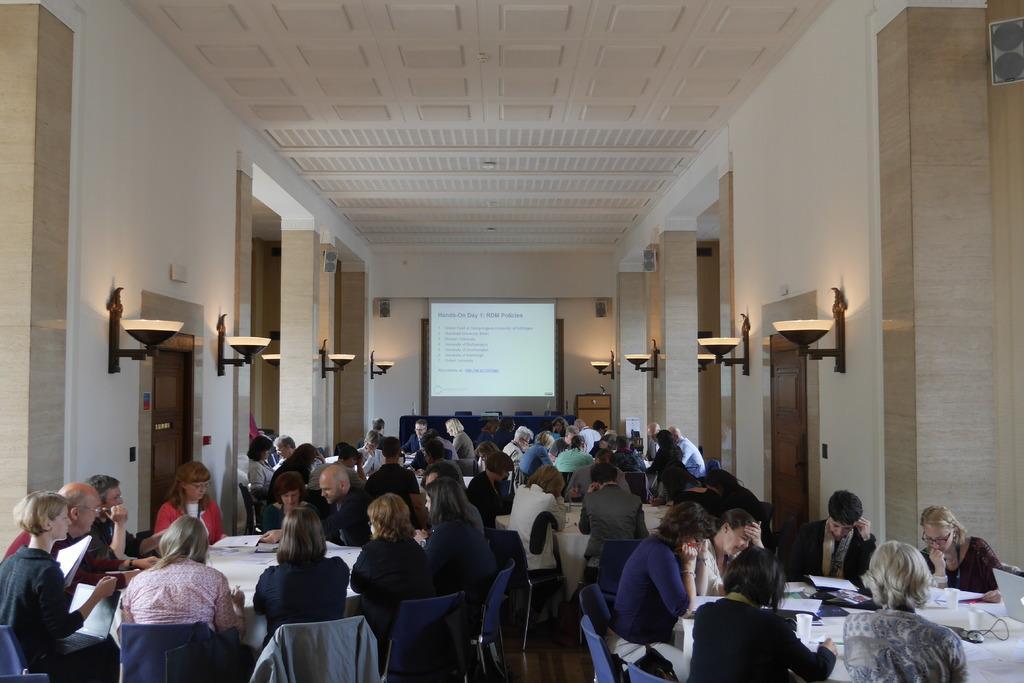How would you summarize this image in a sentence or two? This picture is of inside the hall. In the foreground there are group of persons sitting on the chairs and tables on the top of which glasses, papers and some other items are placed. In the background we can see a projector screen, wall and wall lamps. On the left there is a door and on the top we can see a roof and wall mounted speakers. 